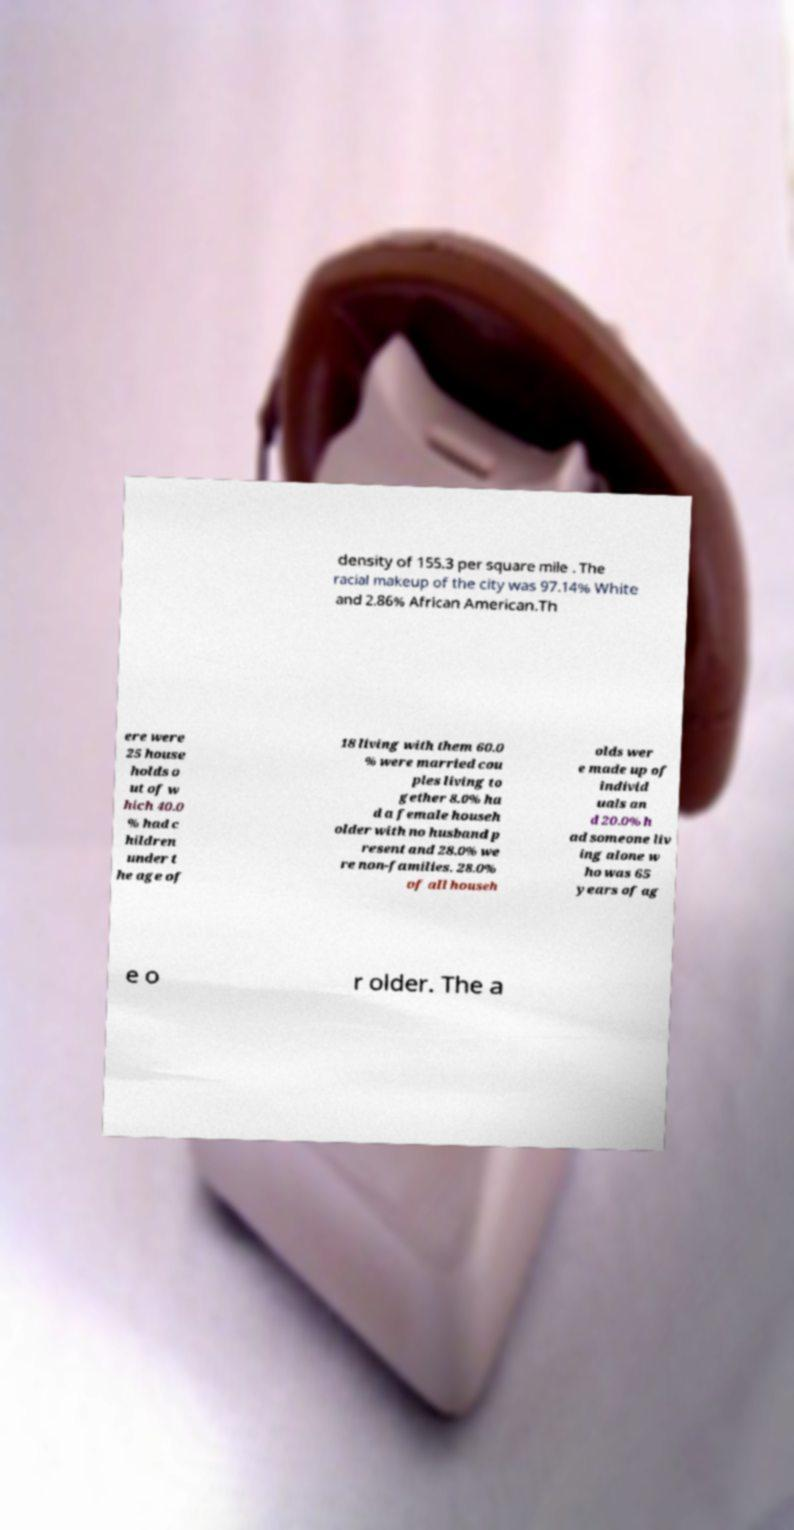Could you extract and type out the text from this image? density of 155.3 per square mile . The racial makeup of the city was 97.14% White and 2.86% African American.Th ere were 25 house holds o ut of w hich 40.0 % had c hildren under t he age of 18 living with them 60.0 % were married cou ples living to gether 8.0% ha d a female househ older with no husband p resent and 28.0% we re non-families. 28.0% of all househ olds wer e made up of individ uals an d 20.0% h ad someone liv ing alone w ho was 65 years of ag e o r older. The a 